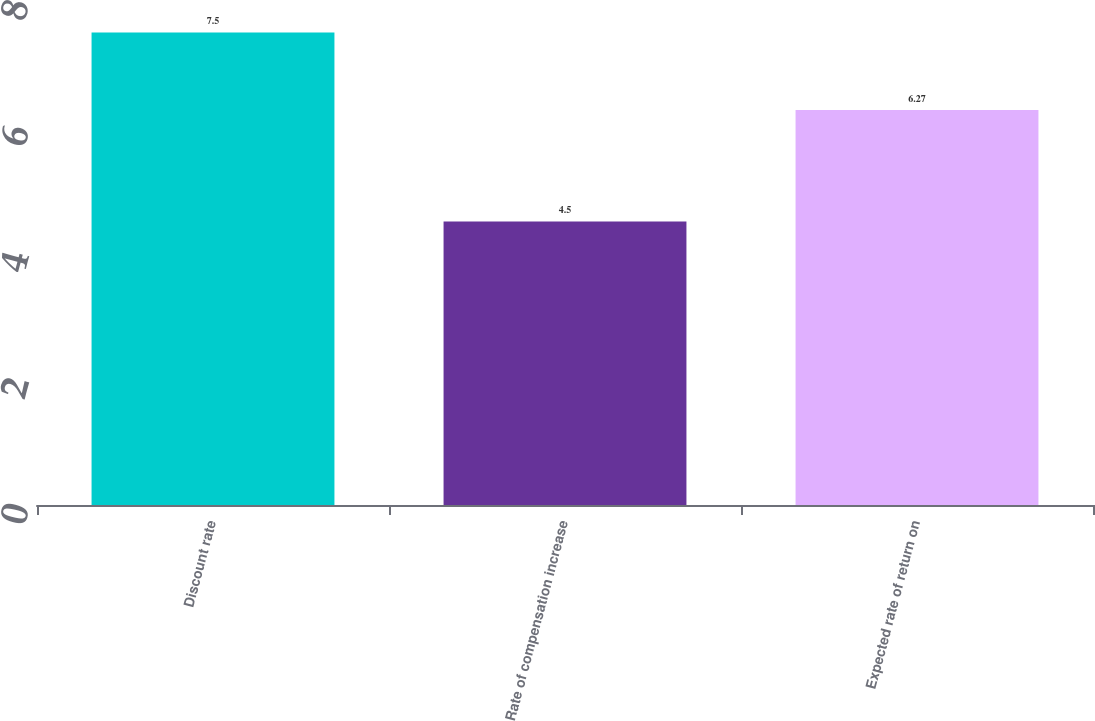Convert chart to OTSL. <chart><loc_0><loc_0><loc_500><loc_500><bar_chart><fcel>Discount rate<fcel>Rate of compensation increase<fcel>Expected rate of return on<nl><fcel>7.5<fcel>4.5<fcel>6.27<nl></chart> 